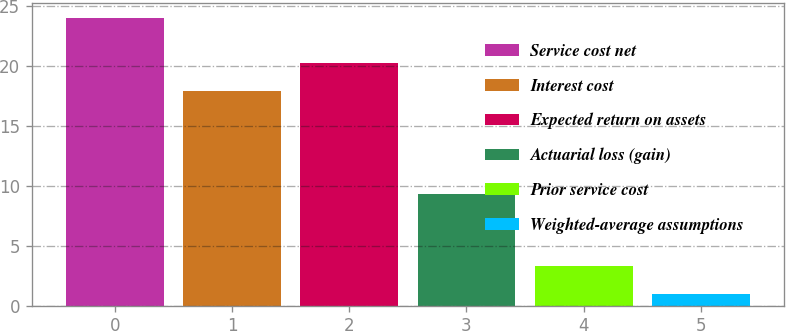<chart> <loc_0><loc_0><loc_500><loc_500><bar_chart><fcel>Service cost net<fcel>Interest cost<fcel>Expected return on assets<fcel>Actuarial loss (gain)<fcel>Prior service cost<fcel>Weighted-average assumptions<nl><fcel>24<fcel>17.9<fcel>20.2<fcel>9.3<fcel>3.3<fcel>1<nl></chart> 